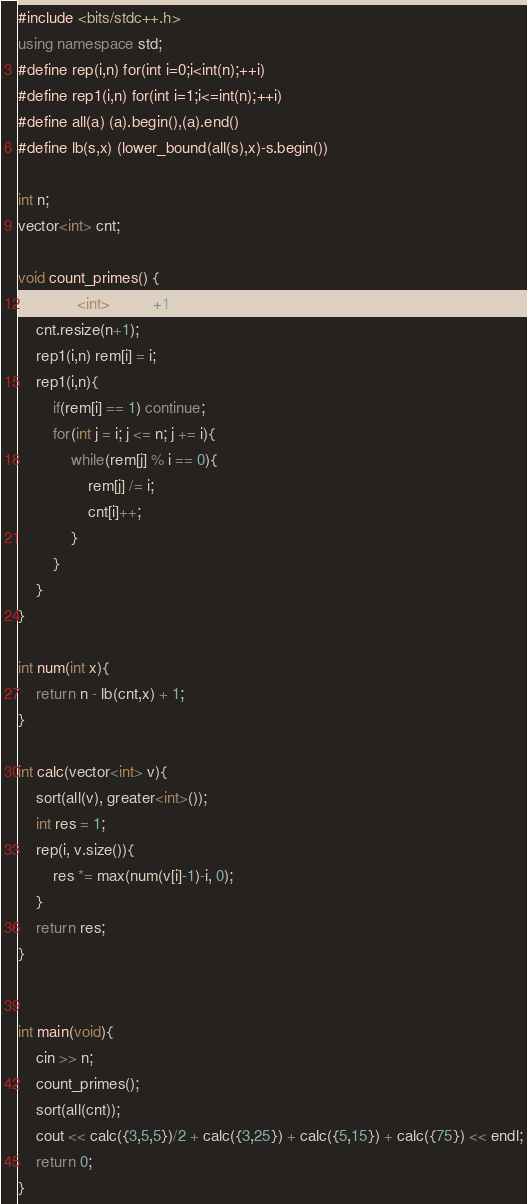<code> <loc_0><loc_0><loc_500><loc_500><_C++_>#include <bits/stdc++.h>
using namespace std;
#define rep(i,n) for(int i=0;i<int(n);++i)
#define rep1(i,n) for(int i=1;i<=int(n);++i)
#define all(a) (a).begin(),(a).end()
#define lb(s,x) (lower_bound(all(s),x)-s.begin())

int n;
vector<int> cnt;

void count_primes() {
    vector<int> rem(n+1);
    cnt.resize(n+1);
    rep1(i,n) rem[i] = i;
    rep1(i,n){
        if(rem[i] == 1) continue;
        for(int j = i; j <= n; j += i){
            while(rem[j] % i == 0){
                rem[j] /= i;
                cnt[i]++;
            }
        }
    }
}

int num(int x){
    return n - lb(cnt,x) + 1;
}

int calc(vector<int> v){
    sort(all(v), greater<int>());
    int res = 1;
    rep(i, v.size()){
        res *= max(num(v[i]-1)-i, 0);
    }
    return res;
}


int main(void){
    cin >> n;
    count_primes();
    sort(all(cnt));
    cout << calc({3,5,5})/2 + calc({3,25}) + calc({5,15}) + calc({75}) << endl;
    return 0;
}
</code> 